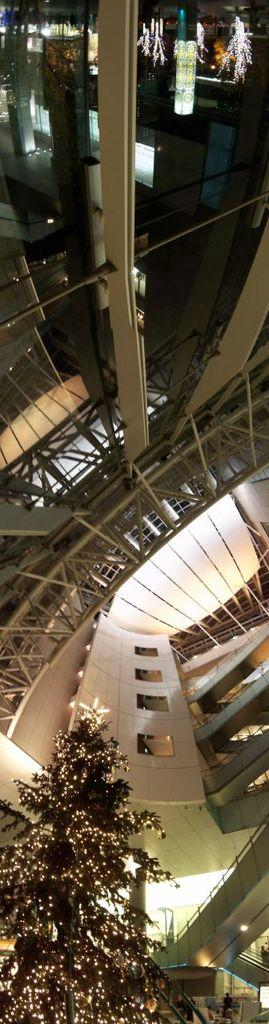What type of material is used for the strings in the image? The strings in the image are made of iron. What type of doors are present in the image? There are glass doors in the image. What architectural feature is visible in the image? There are stairs in the image. What surrounds the area in the image? There are walls in the image. What is the tree at the bottom of the image decorated with? The tree at the bottom of the image is decorated with lights. Can you tell me how many goats are standing on the stairs in the image? There are no goats present in the image; it features iron strings, glass doors, stairs, walls, and a tree decorated with lights. Is there any rain visible in the image? There is no rain present in the image. 